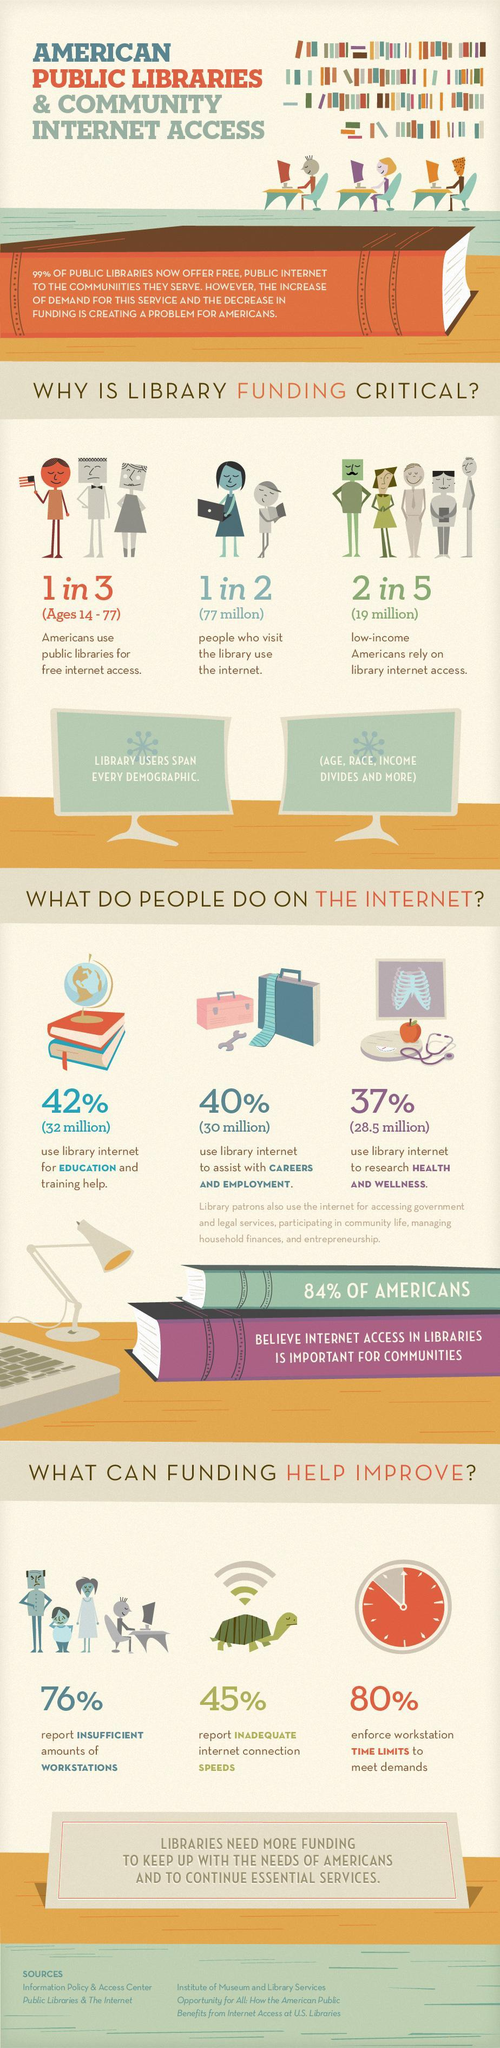What percentage of Americans use library internet to research about health & wellness?
Answer the question with a short phrase. 37% What percentage of Americans use library internet to help with education & training? 42% What population of Americans use library internet to help with careers & employment? 30 million What percentage of Americans do not believe that internet access in libraries are important for communities? 16% What percentage of Americans report inadequate internet connection speeds in libraries? 45% Which age group of Americans use public libraries for free internet access? Ages 14 - 77 How many Americans visit the library to use the internet? 77 million What percentage of Americans report sufficient amounts of workstations in libraries? 24% How many low-income Americans rely on library internet access? 19 million What percentage of Americans do not enforce workstation time limits to meet demands? 20% 